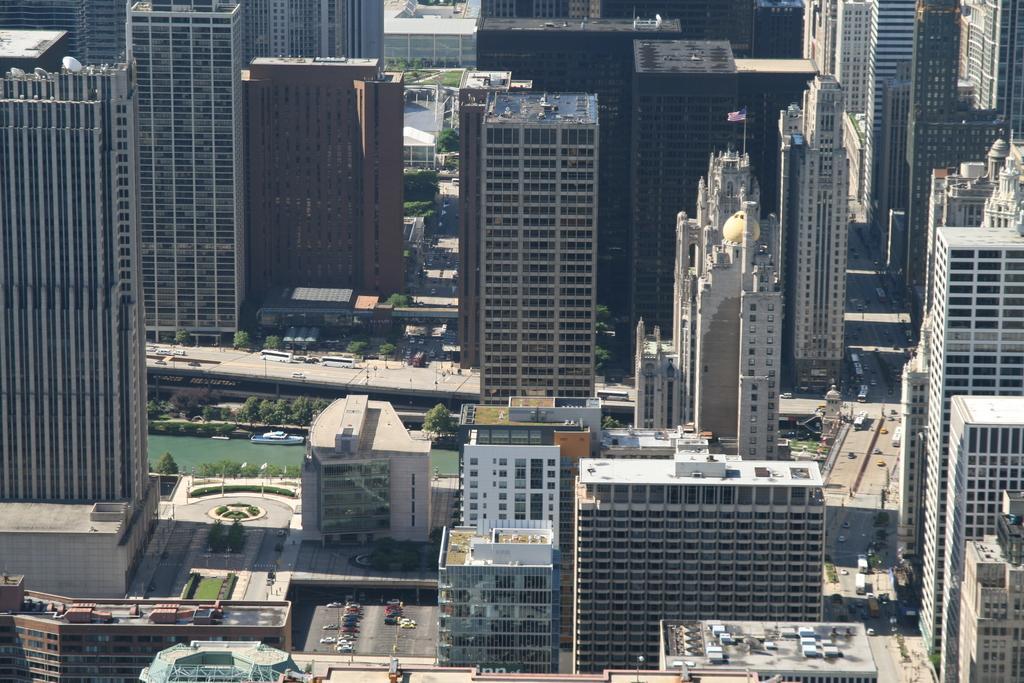In one or two sentences, can you explain what this image depicts? This picture is clicked outside. In the foreground we can see the group of vehicles and we can see the buildings and skyscrapers, water body, trees and many other objects. 